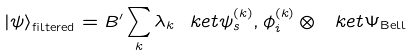Convert formula to latex. <formula><loc_0><loc_0><loc_500><loc_500>\left | \psi \right > _ { \text {filtered} } = B ^ { \prime } \sum _ { k } \lambda _ { k } \ k e t { \psi ^ { ( k ) } _ { s } , \phi ^ { ( k ) } _ { i } } \otimes \ k e t { \Psi } _ { \text {Bell} }</formula> 